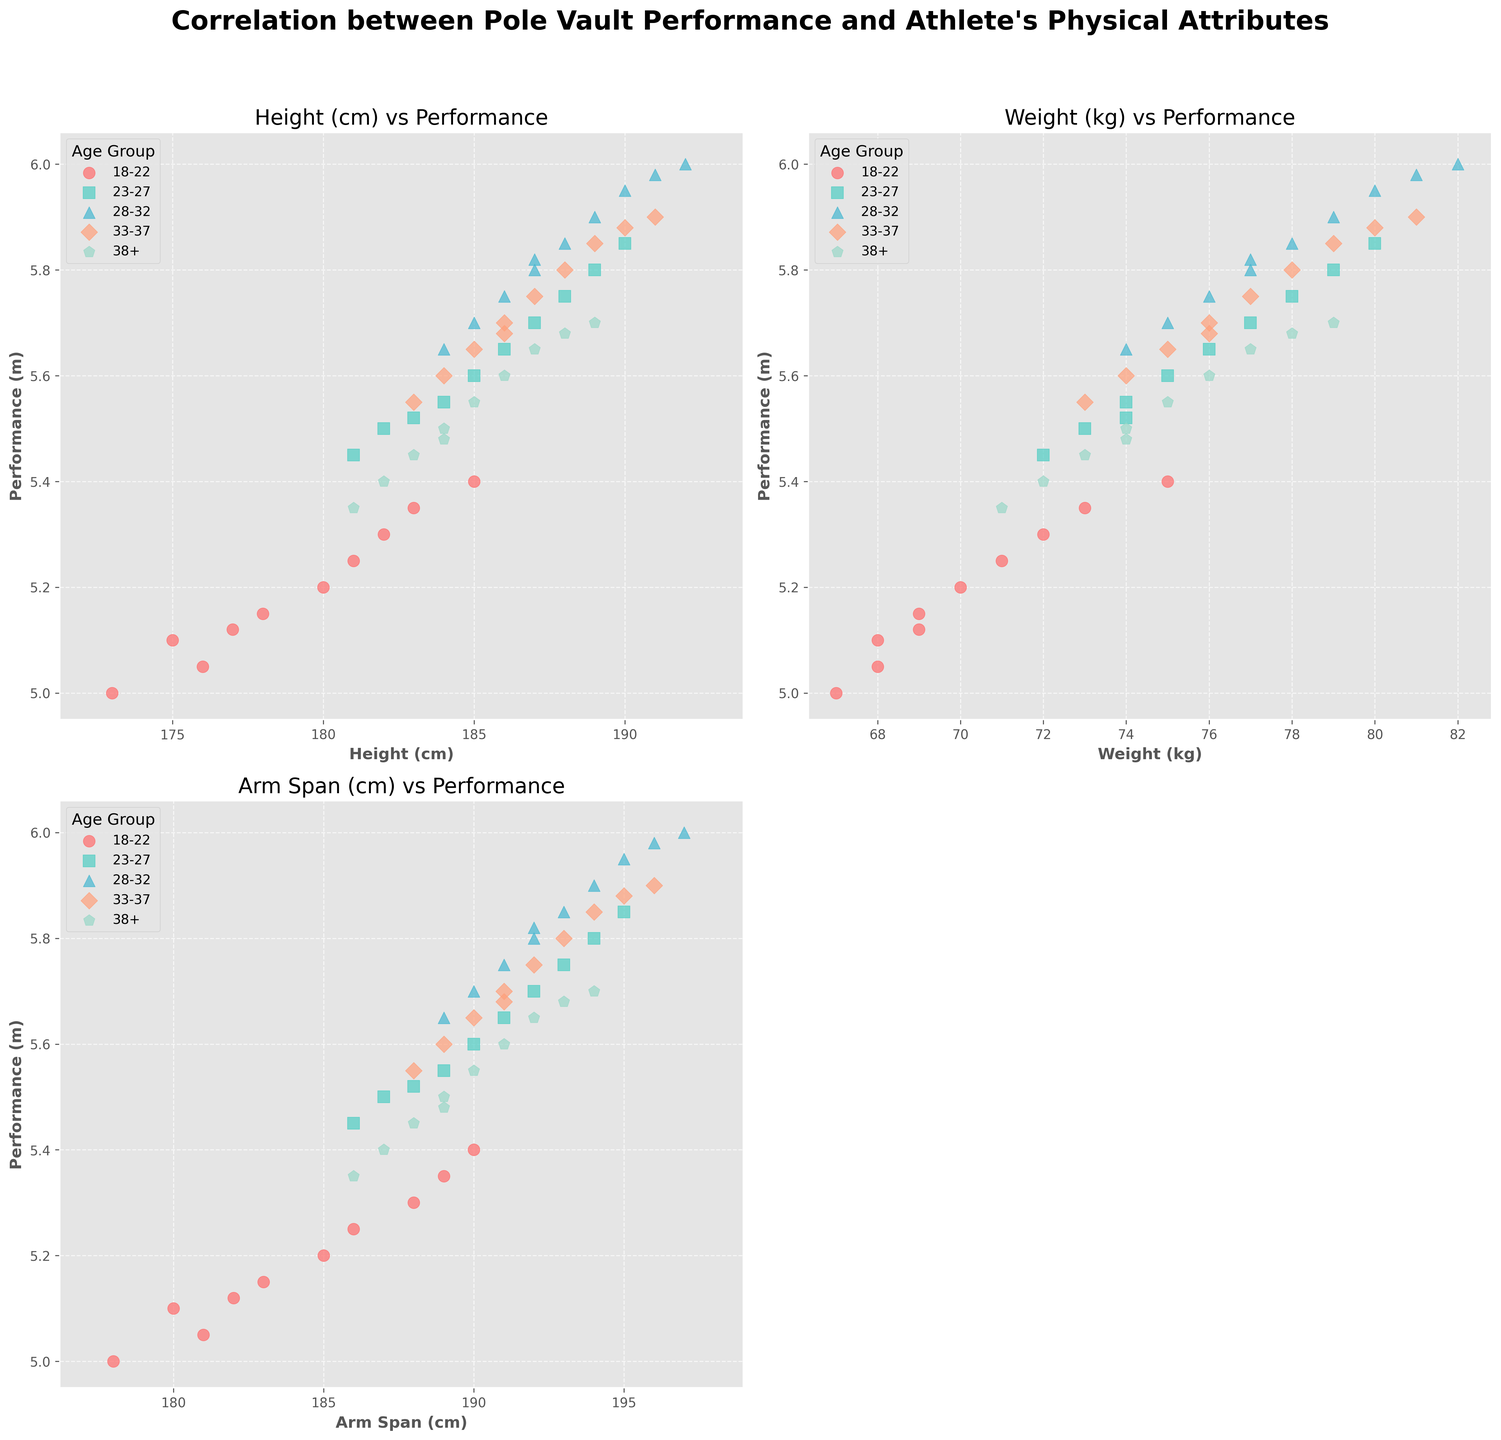What age group has the highest pole vault performance for athletes with weight around 190 cm? Look at the plots and find the group with the maximum performance value for height around 190 cm. The group 28-32 shows the highest performance.
Answer: 28-32 How does pole vault performance change with weight for athletes aged 23-27 compared to those aged 33-37? In the plot of weight vs performance, compare the performance trend line for the 23-27 age group with the 33-37 age group. The 33-37 group shows a generally lower performance trend than the 23-27 group.
Answer: 23-27 have better performance than 33-37 Which age group has the densest clustering of performance relative to height? Observe the height vs performance plot and identify the age group with the most clustered data points. The age group 28-32 has the densest clustering.
Answer: 28-32 Do older athletes (age 38+) generally have a lower pole vault performance compared to the younger athletes (18-22)? Compare the data points of the age group 38+ with those of 18-22 in all plots. The performance values for 38+ are generally lower than those of 18-22.
Answer: Yes What is the trend in pole vault performance with increasing arm span for the oldest age group? Examine the arm span vs performance plot and focus on the data points for the age group 38+. The trend shows a slight increase in performance with increasing arm span.
Answer: Slight increase For which physical attribute is there the least visual correlation with pole vault performance in the 18-22 age group? Compare the spread and trend of performance values relative to height, weight, and arm span for the 18-22 age group. The attribute with the least visual correlation is weight.
Answer: Weight Which age group shows a clear positive correlation between arm span and performance? Observe the arm span vs performance plot and find which age group's data points show a straightforward upward trend. The 28-32 age group shows a clear positive correlation.
Answer: 28-32 What is the performance range for the top-performing age group in terms of height? Identify the age group with the highest performance values in the height vs performance plot, which is 28-32, and determine the range of performance for this group. The performance range is between 5.65m to 6.00m.
Answer: 5.65m to 6.00m 